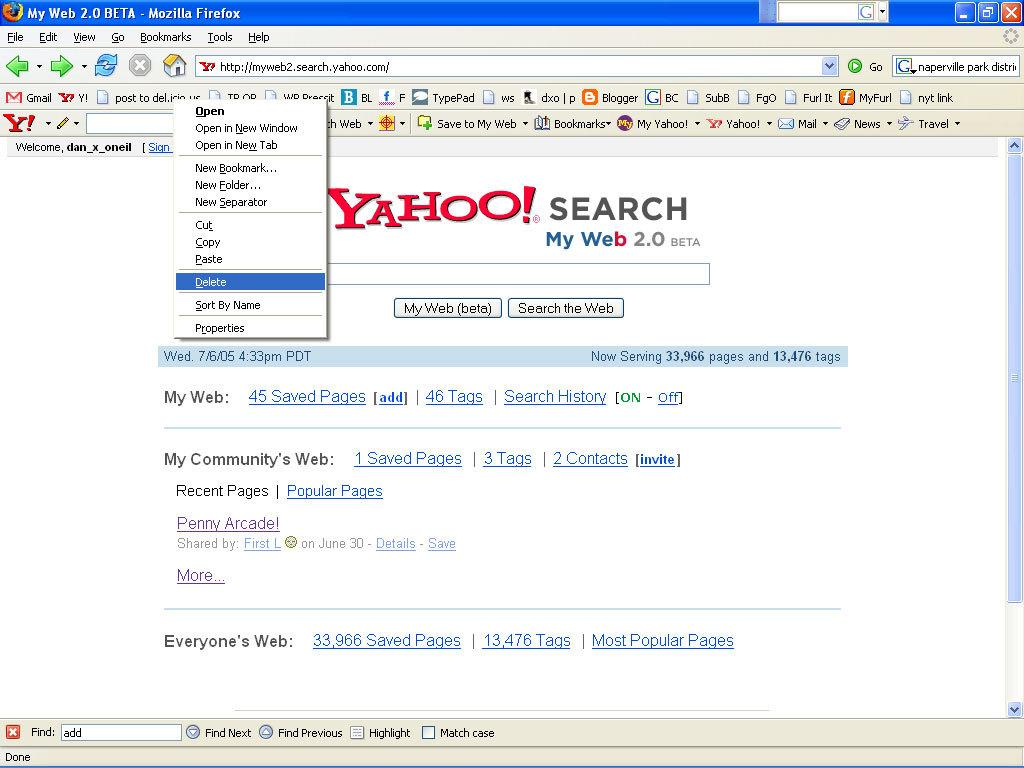<image>
Relay a brief, clear account of the picture shown. A screenshot of a Firefox browser running in Windows XP where the landing page is Yahoo Search. 